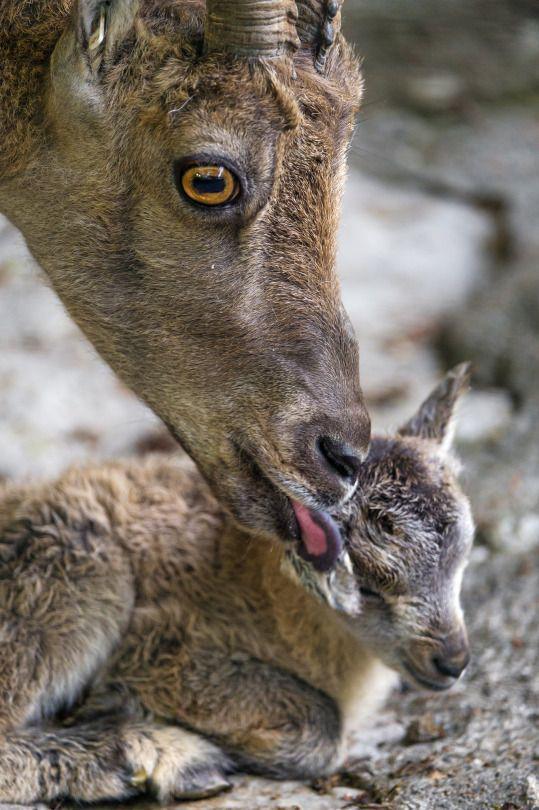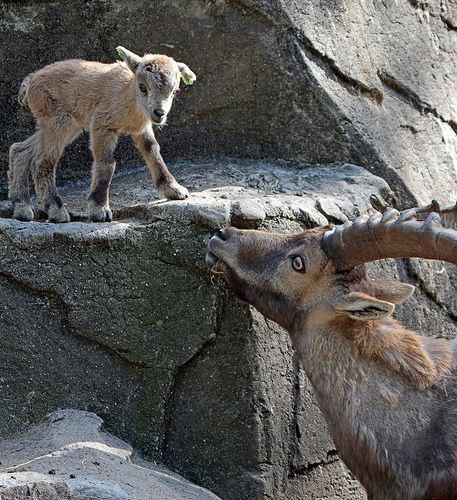The first image is the image on the left, the second image is the image on the right. Assess this claim about the two images: "both animals are facing the same direction.". Correct or not? Answer yes or no. No. 